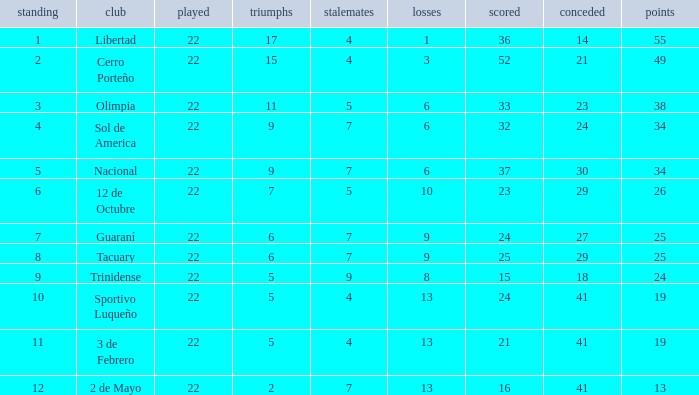What is the fewest wins that has fewer than 23 goals scored, team of 2 de Mayo, and fewer than 7 draws? None. 